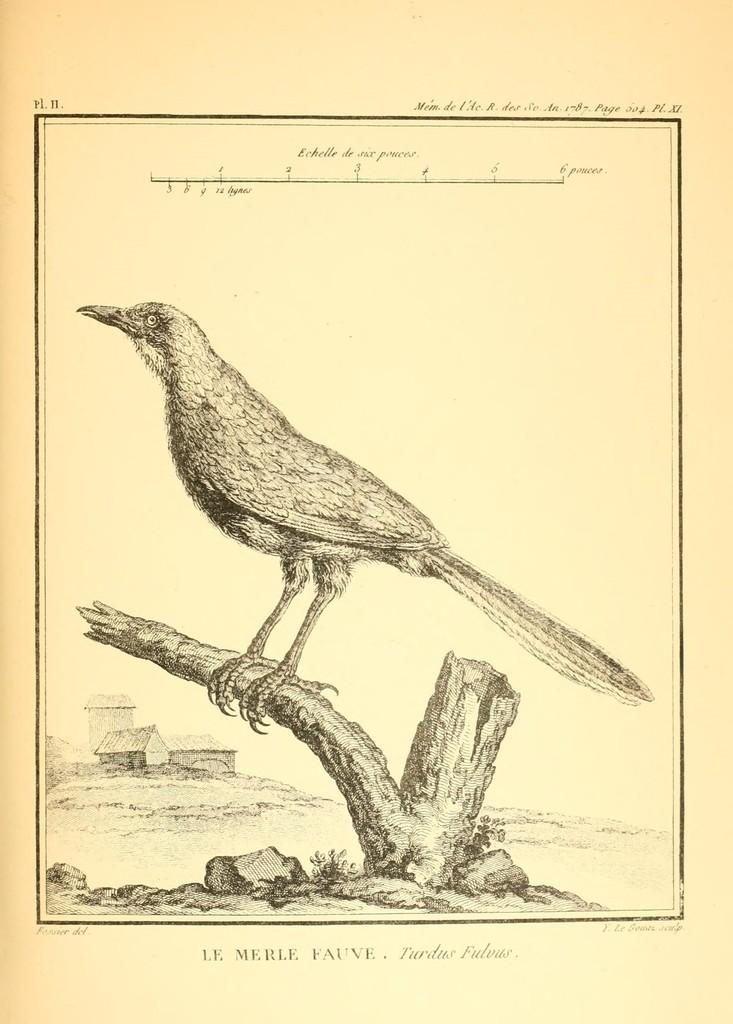What is depicted on the paper in the image? There is a drawing of a bird on the paper. What is the bird doing in the drawing? The bird is standing on a branch in the drawing. What can be seen in the background of the image? There are houses visible in the background. Is there any text on the paper? Yes, there is writing on the paper. What type of steel is used to construct the bird's beak in the image? There is no steel present in the image, as it is a drawing of a bird on paper. How does the light affect the bird's feathers in the image? There is no light source mentioned or depicted in the image, so it is not possible to determine how light might affect the bird's feathers. 